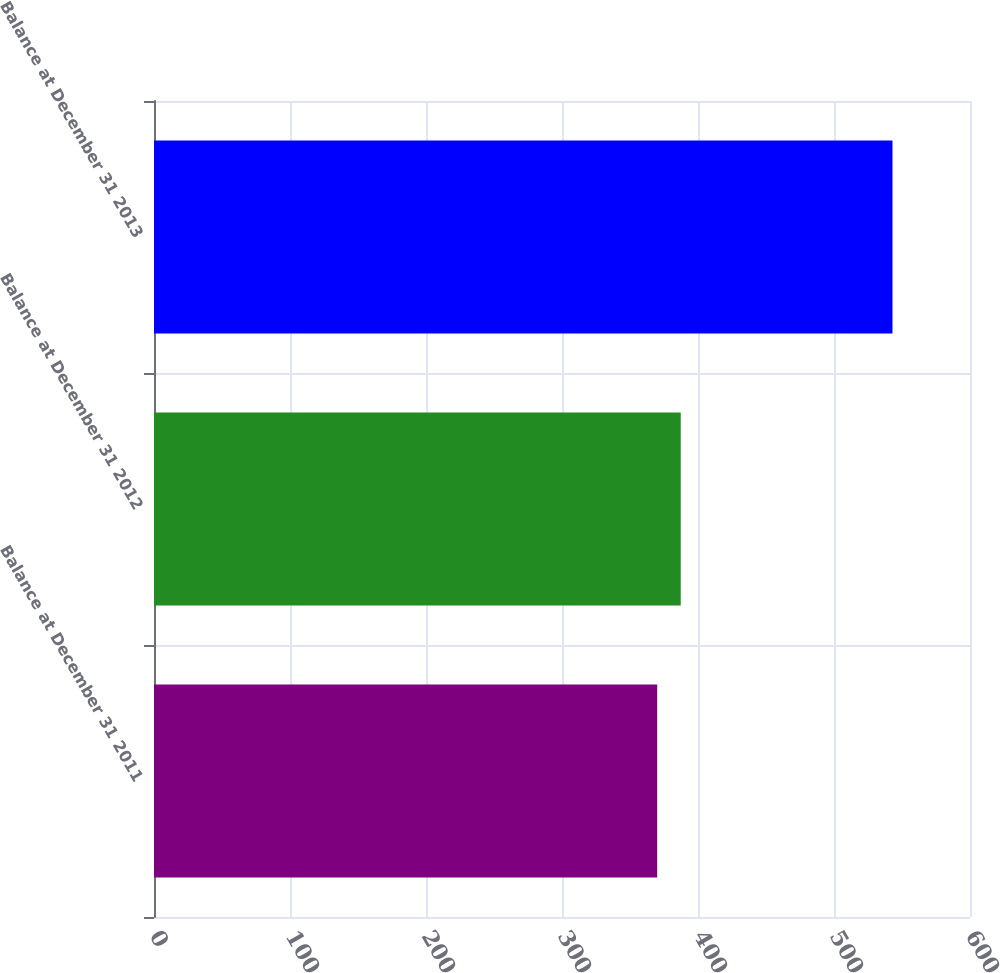Convert chart. <chart><loc_0><loc_0><loc_500><loc_500><bar_chart><fcel>Balance at December 31 2011<fcel>Balance at December 31 2012<fcel>Balance at December 31 2013<nl><fcel>370<fcel>387.3<fcel>543<nl></chart> 